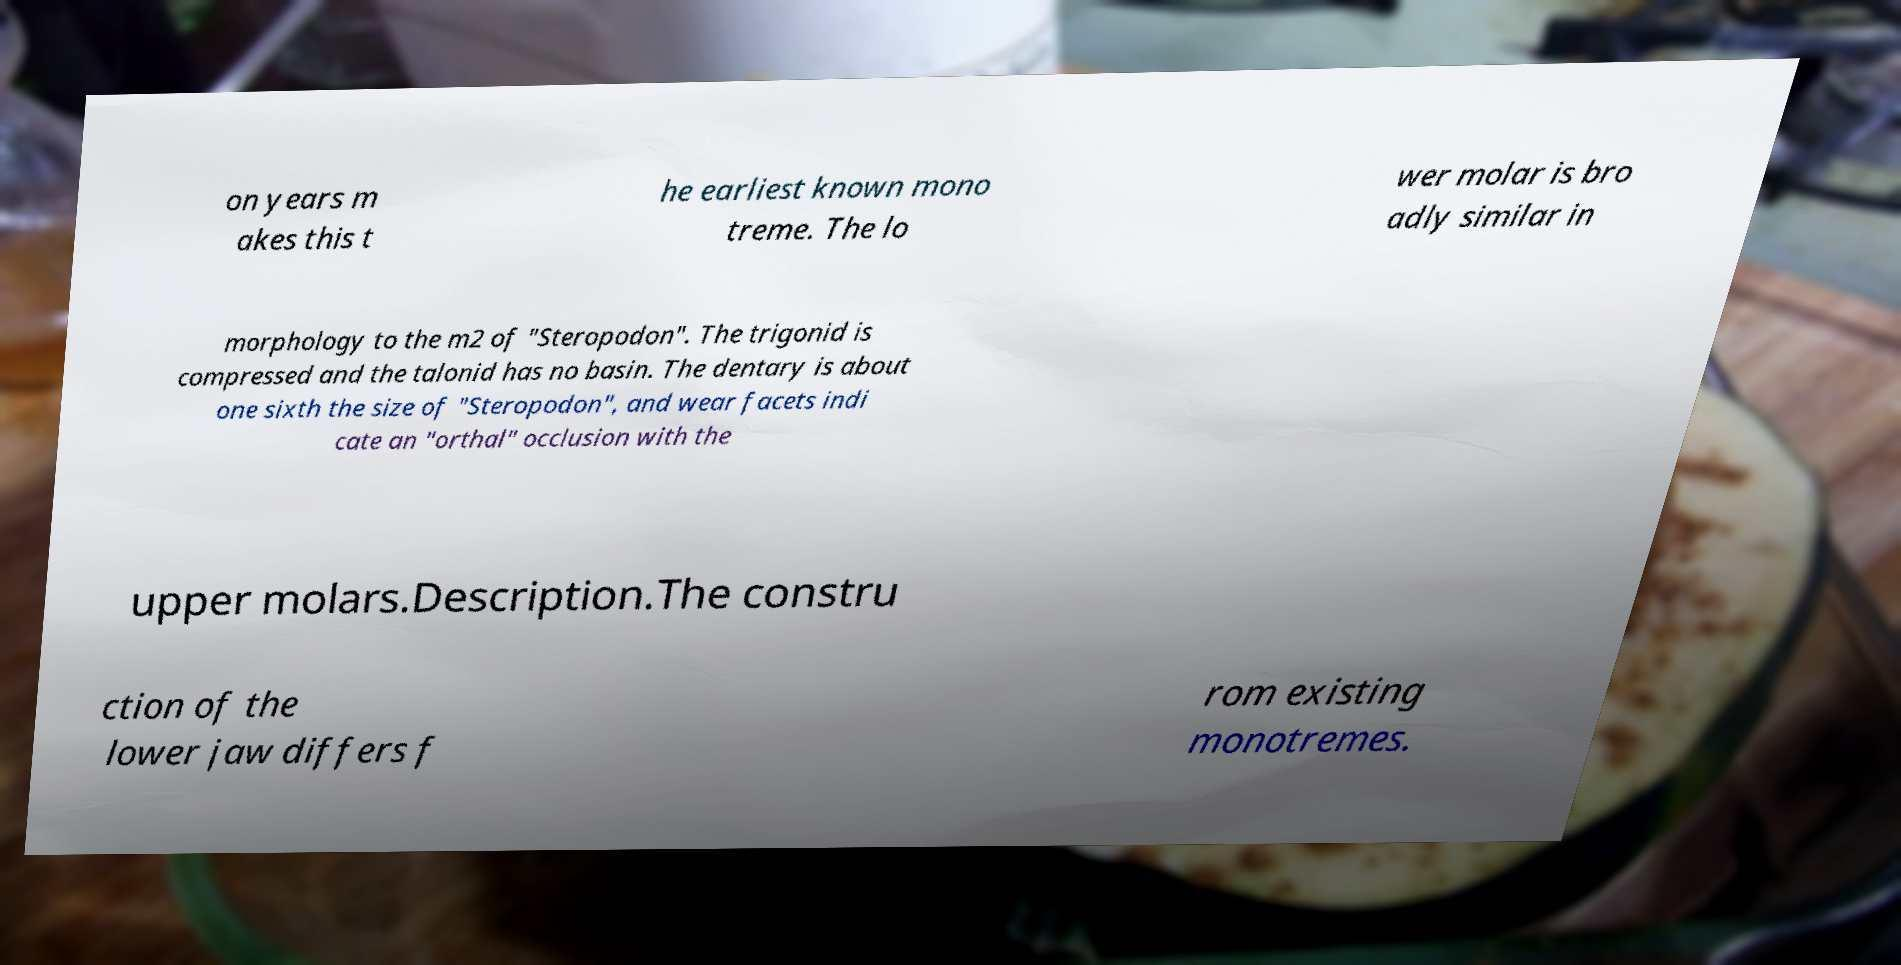For documentation purposes, I need the text within this image transcribed. Could you provide that? on years m akes this t he earliest known mono treme. The lo wer molar is bro adly similar in morphology to the m2 of "Steropodon". The trigonid is compressed and the talonid has no basin. The dentary is about one sixth the size of "Steropodon", and wear facets indi cate an "orthal" occlusion with the upper molars.Description.The constru ction of the lower jaw differs f rom existing monotremes. 